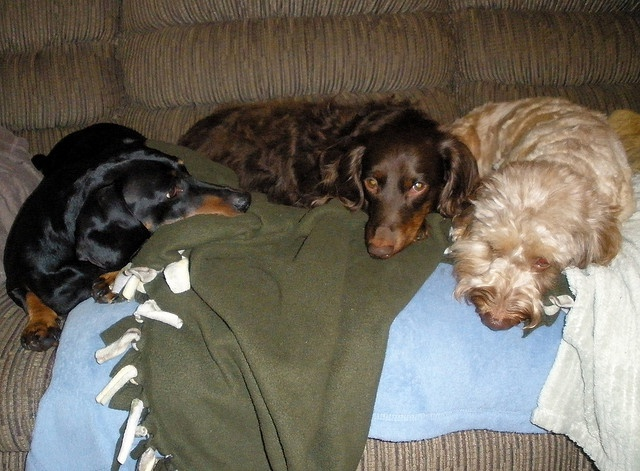Describe the objects in this image and their specific colors. I can see couch in black, gray, lightgray, lightblue, and darkgreen tones, couch in black and gray tones, dog in black, tan, and gray tones, dog in black, maroon, and gray tones, and dog in black, gray, and maroon tones in this image. 